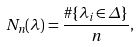Convert formula to latex. <formula><loc_0><loc_0><loc_500><loc_500>N _ { n } ( \lambda ) = \frac { \# \{ \lambda _ { i } \in \Delta \} } { n } ,</formula> 